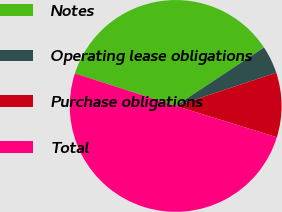Convert chart to OTSL. <chart><loc_0><loc_0><loc_500><loc_500><pie_chart><fcel>Notes<fcel>Operating lease obligations<fcel>Purchase obligations<fcel>Total<nl><fcel>35.73%<fcel>4.23%<fcel>9.85%<fcel>50.18%<nl></chart> 